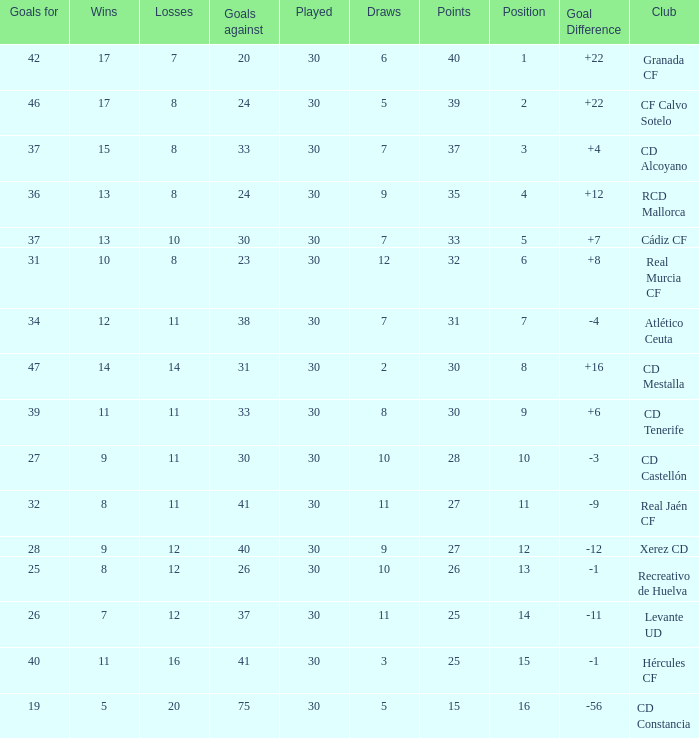Which Played has a Club of atlético ceuta, and less than 11 Losses? None. 